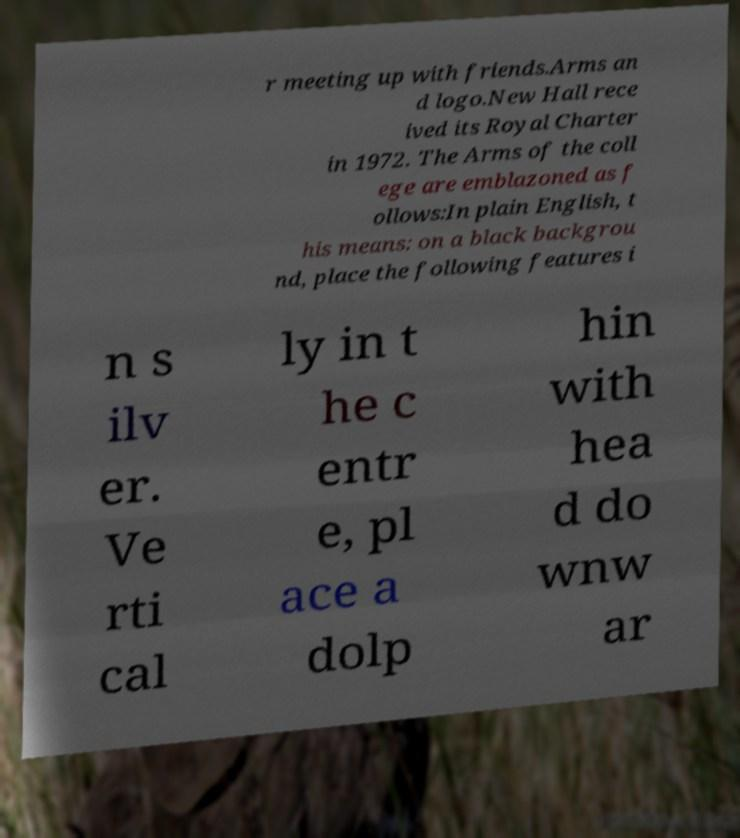Can you accurately transcribe the text from the provided image for me? r meeting up with friends.Arms an d logo.New Hall rece ived its Royal Charter in 1972. The Arms of the coll ege are emblazoned as f ollows:In plain English, t his means: on a black backgrou nd, place the following features i n s ilv er. Ve rti cal ly in t he c entr e, pl ace a dolp hin with hea d do wnw ar 